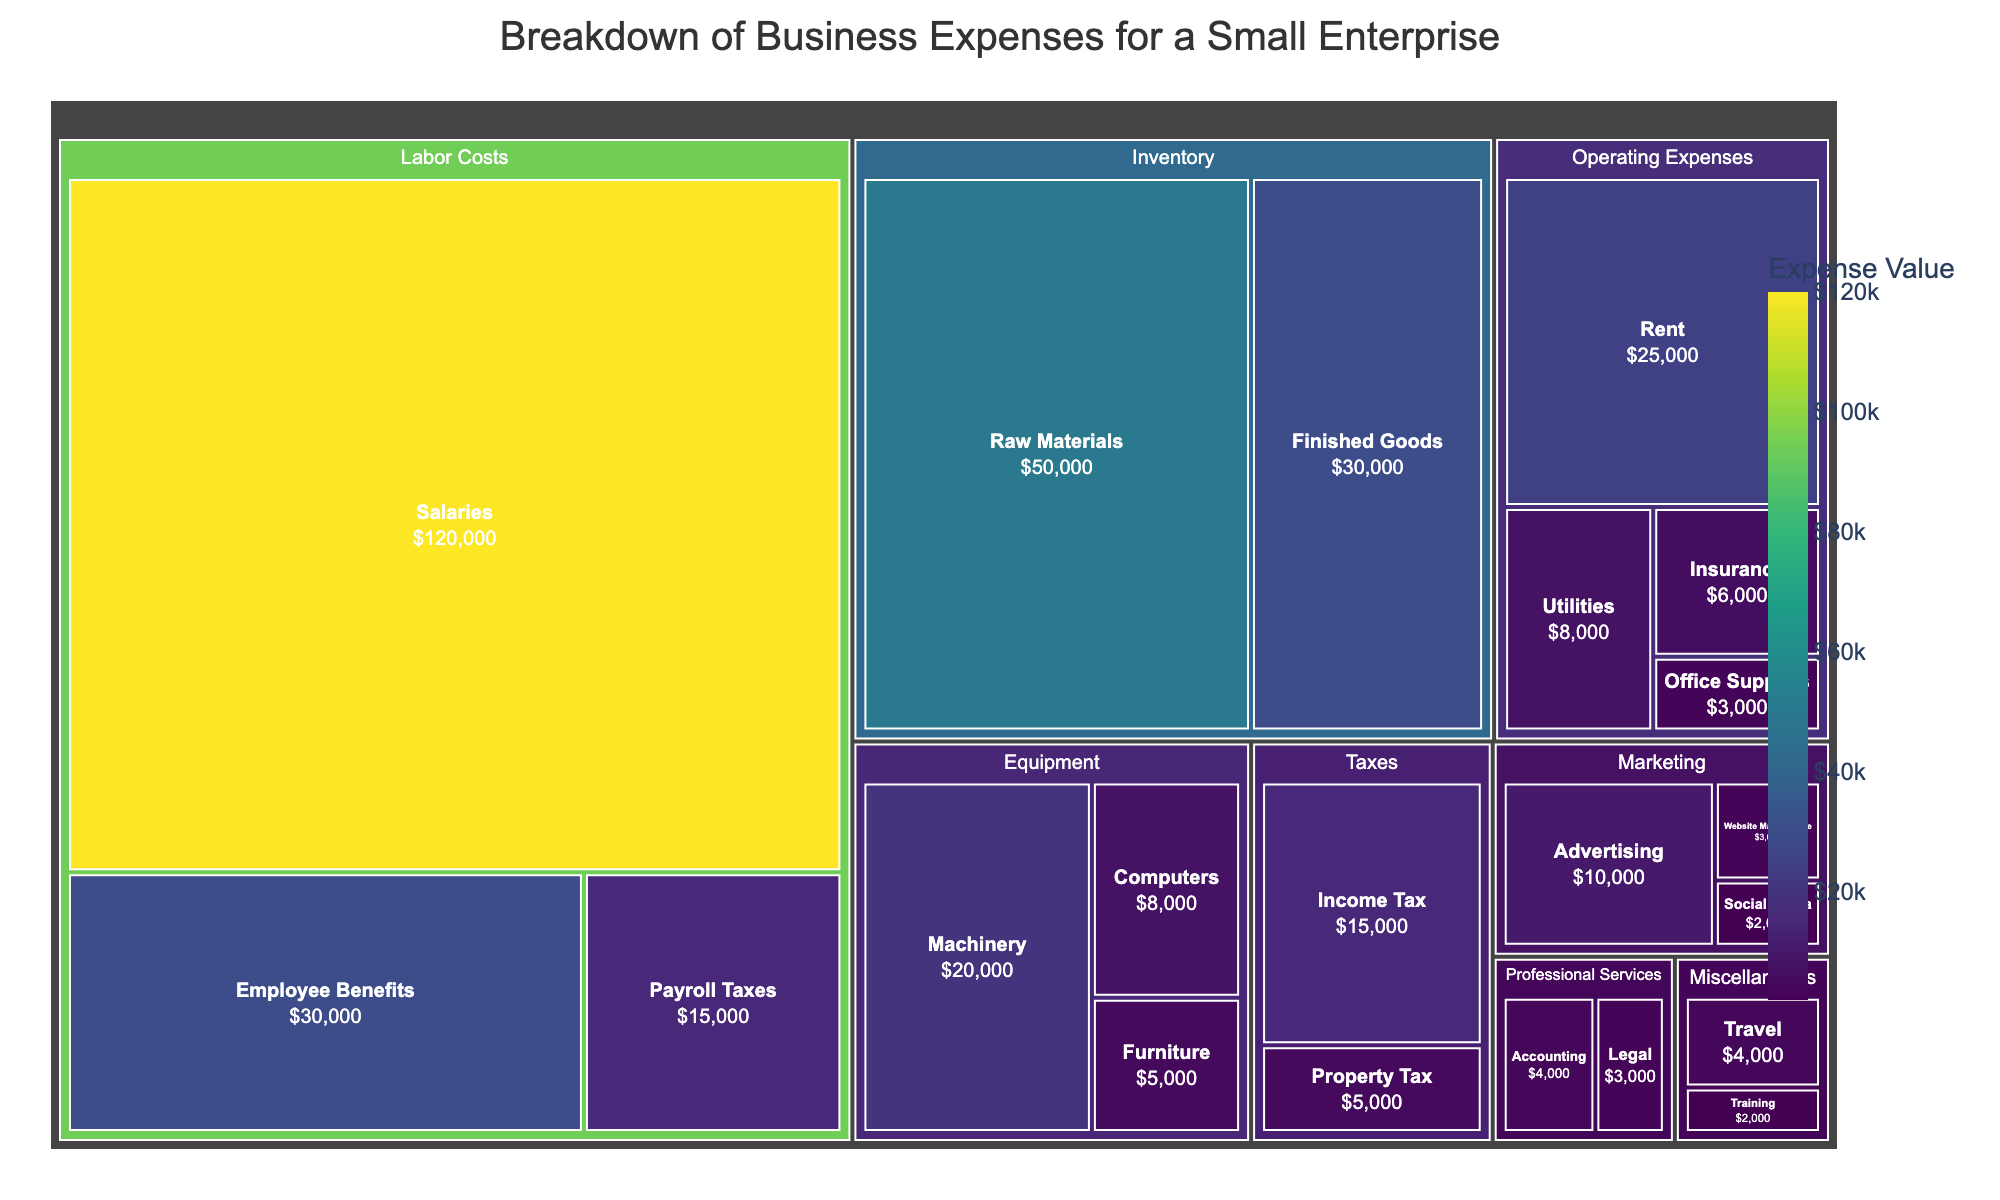What is the title of the treemap? The title is usually placed at the top of the figure. Here, it reads "Breakdown of Business Expenses for a Small Enterprise."
Answer: Breakdown of Business Expenses for a Small Enterprise Which category has the highest individual expense? The largest tile within each category represents the highest expense. The "Salaries" subcategory within "Labor Costs" has the largest tile, indicating the highest expense.
Answer: Labor Costs - Salaries What is the total expense for the Marketing category? By summing the values of all subcategories under Marketing (Advertising: $10,000, Website Maintenance: $3,000, Social Media: $2,000), we get a total. $10,000 + $3,000 + $2,000 = $15,000.
Answer: $15,000 Compare the expenses for Rent and Utilities. Which one is higher and by how much? The Rent expense is $25,000 and the Utilities expense is $8,000. The difference is $25,000 - $8,000 = $17,000.
Answer: Rent is higher by $17,000 How much more is spent on Salaries compared to Raw Materials? The Salaries expense is $120,000 and the Raw Materials expense is $50,000. The difference is $120,000 - $50,000 = $70,000.
Answer: $70,000 What percentage of the total expenses does the Employee Benefits subcategory represent? The Employee Benefits expense is $30,000. To find the total of all expenses, sum all values: $350,000. The percentage is ($30,000 / $350,000) * 100 ≈ 8.57%.
Answer: ≈ 8.57% Which category has the smallest total expense and what is its value? By examining the tiles, "Miscellaneous" has the smallest total made up of Travel ($4,000) and Training ($2,000). Total: $4,000 + $2,000 = $6,000.
Answer: Miscellaneous - $6,000 Identify the subcategory with the lowest expense and specify its value. The smallest tile indicates the lowest expense. Social Media in Marketing has the lowest expense at $2,000.
Answer: Social Media - $2,000 What is the combined expense for Equipment and Professional Services categories? Summing the values for Equipment (Machinery: $20,000, Computers: $8,000, Furniture: $5,000) and Professional Services (Accounting: $4,000, Legal: $3,000): $20,000 + $8,000 + $5,000 + $4,000 + $3,000 = $40,000.
Answer: $40,000 